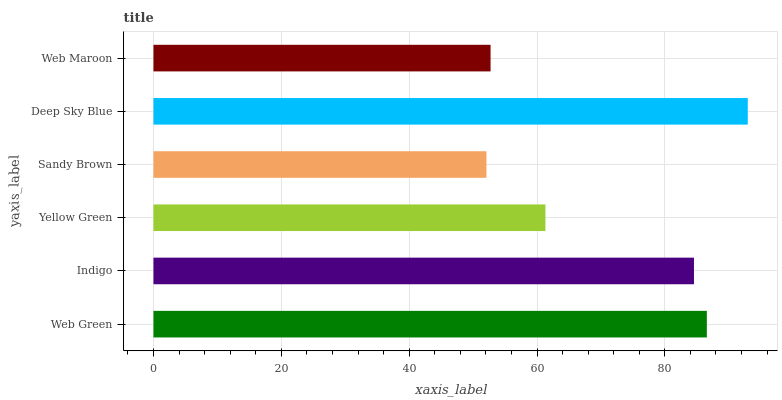Is Sandy Brown the minimum?
Answer yes or no. Yes. Is Deep Sky Blue the maximum?
Answer yes or no. Yes. Is Indigo the minimum?
Answer yes or no. No. Is Indigo the maximum?
Answer yes or no. No. Is Web Green greater than Indigo?
Answer yes or no. Yes. Is Indigo less than Web Green?
Answer yes or no. Yes. Is Indigo greater than Web Green?
Answer yes or no. No. Is Web Green less than Indigo?
Answer yes or no. No. Is Indigo the high median?
Answer yes or no. Yes. Is Yellow Green the low median?
Answer yes or no. Yes. Is Web Maroon the high median?
Answer yes or no. No. Is Indigo the low median?
Answer yes or no. No. 